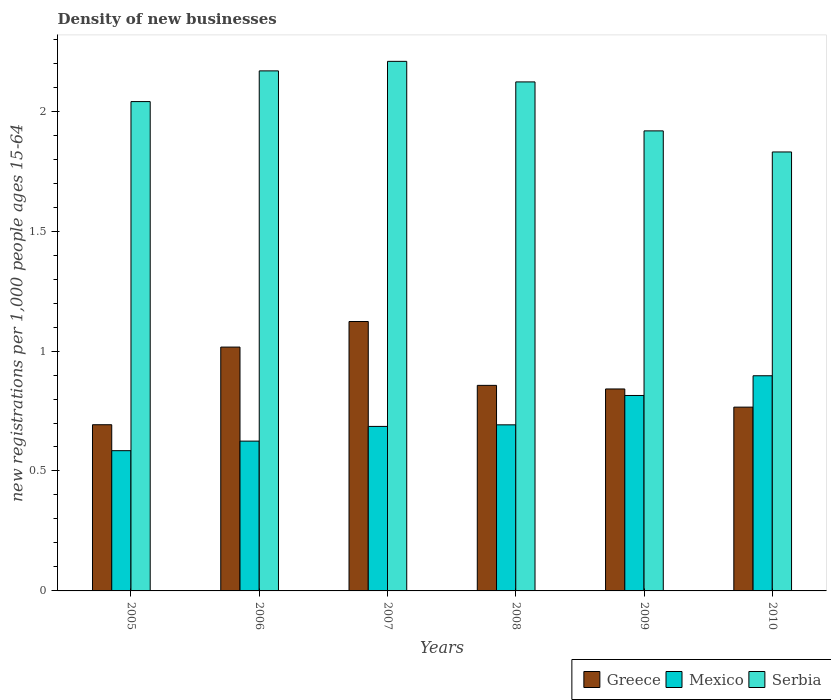How many different coloured bars are there?
Your answer should be very brief. 3. Are the number of bars per tick equal to the number of legend labels?
Your answer should be very brief. Yes. Are the number of bars on each tick of the X-axis equal?
Keep it short and to the point. Yes. What is the number of new registrations in Mexico in 2005?
Keep it short and to the point. 0.58. Across all years, what is the maximum number of new registrations in Greece?
Your answer should be very brief. 1.12. Across all years, what is the minimum number of new registrations in Greece?
Your answer should be compact. 0.69. What is the total number of new registrations in Serbia in the graph?
Provide a succinct answer. 12.29. What is the difference between the number of new registrations in Mexico in 2005 and that in 2006?
Provide a short and direct response. -0.04. What is the difference between the number of new registrations in Serbia in 2007 and the number of new registrations in Mexico in 2009?
Your answer should be compact. 1.39. What is the average number of new registrations in Serbia per year?
Offer a very short reply. 2.05. In the year 2005, what is the difference between the number of new registrations in Mexico and number of new registrations in Greece?
Your answer should be very brief. -0.11. What is the ratio of the number of new registrations in Mexico in 2008 to that in 2010?
Your answer should be compact. 0.77. What is the difference between the highest and the second highest number of new registrations in Mexico?
Keep it short and to the point. 0.08. What is the difference between the highest and the lowest number of new registrations in Greece?
Provide a short and direct response. 0.43. In how many years, is the number of new registrations in Mexico greater than the average number of new registrations in Mexico taken over all years?
Offer a very short reply. 2. Is the sum of the number of new registrations in Greece in 2005 and 2008 greater than the maximum number of new registrations in Mexico across all years?
Your answer should be compact. Yes. What does the 3rd bar from the left in 2008 represents?
Offer a very short reply. Serbia. What does the 1st bar from the right in 2005 represents?
Give a very brief answer. Serbia. Is it the case that in every year, the sum of the number of new registrations in Mexico and number of new registrations in Serbia is greater than the number of new registrations in Greece?
Offer a terse response. Yes. Are all the bars in the graph horizontal?
Make the answer very short. No. How many years are there in the graph?
Offer a very short reply. 6. What is the difference between two consecutive major ticks on the Y-axis?
Offer a very short reply. 0.5. Are the values on the major ticks of Y-axis written in scientific E-notation?
Your answer should be very brief. No. Where does the legend appear in the graph?
Keep it short and to the point. Bottom right. How many legend labels are there?
Ensure brevity in your answer.  3. How are the legend labels stacked?
Offer a terse response. Horizontal. What is the title of the graph?
Offer a terse response. Density of new businesses. What is the label or title of the Y-axis?
Your answer should be very brief. New registrations per 1,0 people ages 15-64. What is the new registrations per 1,000 people ages 15-64 of Greece in 2005?
Keep it short and to the point. 0.69. What is the new registrations per 1,000 people ages 15-64 of Mexico in 2005?
Offer a very short reply. 0.58. What is the new registrations per 1,000 people ages 15-64 in Serbia in 2005?
Make the answer very short. 2.04. What is the new registrations per 1,000 people ages 15-64 of Greece in 2006?
Ensure brevity in your answer.  1.02. What is the new registrations per 1,000 people ages 15-64 of Mexico in 2006?
Give a very brief answer. 0.62. What is the new registrations per 1,000 people ages 15-64 of Serbia in 2006?
Ensure brevity in your answer.  2.17. What is the new registrations per 1,000 people ages 15-64 of Greece in 2007?
Keep it short and to the point. 1.12. What is the new registrations per 1,000 people ages 15-64 of Mexico in 2007?
Offer a terse response. 0.69. What is the new registrations per 1,000 people ages 15-64 in Serbia in 2007?
Your answer should be compact. 2.21. What is the new registrations per 1,000 people ages 15-64 in Greece in 2008?
Offer a very short reply. 0.86. What is the new registrations per 1,000 people ages 15-64 of Mexico in 2008?
Provide a short and direct response. 0.69. What is the new registrations per 1,000 people ages 15-64 of Serbia in 2008?
Provide a short and direct response. 2.12. What is the new registrations per 1,000 people ages 15-64 of Greece in 2009?
Offer a very short reply. 0.84. What is the new registrations per 1,000 people ages 15-64 in Mexico in 2009?
Give a very brief answer. 0.81. What is the new registrations per 1,000 people ages 15-64 in Serbia in 2009?
Provide a succinct answer. 1.92. What is the new registrations per 1,000 people ages 15-64 in Greece in 2010?
Offer a terse response. 0.77. What is the new registrations per 1,000 people ages 15-64 of Mexico in 2010?
Give a very brief answer. 0.9. What is the new registrations per 1,000 people ages 15-64 in Serbia in 2010?
Keep it short and to the point. 1.83. Across all years, what is the maximum new registrations per 1,000 people ages 15-64 of Greece?
Ensure brevity in your answer.  1.12. Across all years, what is the maximum new registrations per 1,000 people ages 15-64 of Mexico?
Your answer should be compact. 0.9. Across all years, what is the maximum new registrations per 1,000 people ages 15-64 of Serbia?
Provide a succinct answer. 2.21. Across all years, what is the minimum new registrations per 1,000 people ages 15-64 of Greece?
Provide a succinct answer. 0.69. Across all years, what is the minimum new registrations per 1,000 people ages 15-64 of Mexico?
Offer a very short reply. 0.58. Across all years, what is the minimum new registrations per 1,000 people ages 15-64 of Serbia?
Offer a terse response. 1.83. What is the total new registrations per 1,000 people ages 15-64 of Greece in the graph?
Make the answer very short. 5.3. What is the total new registrations per 1,000 people ages 15-64 in Mexico in the graph?
Keep it short and to the point. 4.3. What is the total new registrations per 1,000 people ages 15-64 of Serbia in the graph?
Offer a very short reply. 12.29. What is the difference between the new registrations per 1,000 people ages 15-64 in Greece in 2005 and that in 2006?
Offer a terse response. -0.32. What is the difference between the new registrations per 1,000 people ages 15-64 in Mexico in 2005 and that in 2006?
Ensure brevity in your answer.  -0.04. What is the difference between the new registrations per 1,000 people ages 15-64 in Serbia in 2005 and that in 2006?
Your answer should be very brief. -0.13. What is the difference between the new registrations per 1,000 people ages 15-64 of Greece in 2005 and that in 2007?
Your response must be concise. -0.43. What is the difference between the new registrations per 1,000 people ages 15-64 of Mexico in 2005 and that in 2007?
Offer a terse response. -0.1. What is the difference between the new registrations per 1,000 people ages 15-64 of Serbia in 2005 and that in 2007?
Make the answer very short. -0.17. What is the difference between the new registrations per 1,000 people ages 15-64 in Greece in 2005 and that in 2008?
Offer a very short reply. -0.16. What is the difference between the new registrations per 1,000 people ages 15-64 in Mexico in 2005 and that in 2008?
Your response must be concise. -0.11. What is the difference between the new registrations per 1,000 people ages 15-64 of Serbia in 2005 and that in 2008?
Your response must be concise. -0.08. What is the difference between the new registrations per 1,000 people ages 15-64 in Greece in 2005 and that in 2009?
Your response must be concise. -0.15. What is the difference between the new registrations per 1,000 people ages 15-64 in Mexico in 2005 and that in 2009?
Your answer should be compact. -0.23. What is the difference between the new registrations per 1,000 people ages 15-64 of Serbia in 2005 and that in 2009?
Offer a terse response. 0.12. What is the difference between the new registrations per 1,000 people ages 15-64 in Greece in 2005 and that in 2010?
Offer a terse response. -0.07. What is the difference between the new registrations per 1,000 people ages 15-64 in Mexico in 2005 and that in 2010?
Give a very brief answer. -0.31. What is the difference between the new registrations per 1,000 people ages 15-64 in Serbia in 2005 and that in 2010?
Your answer should be very brief. 0.21. What is the difference between the new registrations per 1,000 people ages 15-64 of Greece in 2006 and that in 2007?
Provide a short and direct response. -0.11. What is the difference between the new registrations per 1,000 people ages 15-64 of Mexico in 2006 and that in 2007?
Make the answer very short. -0.06. What is the difference between the new registrations per 1,000 people ages 15-64 of Serbia in 2006 and that in 2007?
Your answer should be very brief. -0.04. What is the difference between the new registrations per 1,000 people ages 15-64 in Greece in 2006 and that in 2008?
Your answer should be compact. 0.16. What is the difference between the new registrations per 1,000 people ages 15-64 in Mexico in 2006 and that in 2008?
Offer a very short reply. -0.07. What is the difference between the new registrations per 1,000 people ages 15-64 of Serbia in 2006 and that in 2008?
Keep it short and to the point. 0.05. What is the difference between the new registrations per 1,000 people ages 15-64 in Greece in 2006 and that in 2009?
Provide a short and direct response. 0.17. What is the difference between the new registrations per 1,000 people ages 15-64 in Mexico in 2006 and that in 2009?
Provide a short and direct response. -0.19. What is the difference between the new registrations per 1,000 people ages 15-64 in Serbia in 2006 and that in 2009?
Your answer should be compact. 0.25. What is the difference between the new registrations per 1,000 people ages 15-64 in Greece in 2006 and that in 2010?
Offer a terse response. 0.25. What is the difference between the new registrations per 1,000 people ages 15-64 of Mexico in 2006 and that in 2010?
Ensure brevity in your answer.  -0.27. What is the difference between the new registrations per 1,000 people ages 15-64 of Serbia in 2006 and that in 2010?
Keep it short and to the point. 0.34. What is the difference between the new registrations per 1,000 people ages 15-64 of Greece in 2007 and that in 2008?
Keep it short and to the point. 0.27. What is the difference between the new registrations per 1,000 people ages 15-64 of Mexico in 2007 and that in 2008?
Your answer should be very brief. -0.01. What is the difference between the new registrations per 1,000 people ages 15-64 of Serbia in 2007 and that in 2008?
Offer a terse response. 0.09. What is the difference between the new registrations per 1,000 people ages 15-64 of Greece in 2007 and that in 2009?
Offer a very short reply. 0.28. What is the difference between the new registrations per 1,000 people ages 15-64 in Mexico in 2007 and that in 2009?
Give a very brief answer. -0.13. What is the difference between the new registrations per 1,000 people ages 15-64 of Serbia in 2007 and that in 2009?
Ensure brevity in your answer.  0.29. What is the difference between the new registrations per 1,000 people ages 15-64 in Greece in 2007 and that in 2010?
Provide a short and direct response. 0.36. What is the difference between the new registrations per 1,000 people ages 15-64 in Mexico in 2007 and that in 2010?
Provide a short and direct response. -0.21. What is the difference between the new registrations per 1,000 people ages 15-64 of Serbia in 2007 and that in 2010?
Make the answer very short. 0.38. What is the difference between the new registrations per 1,000 people ages 15-64 in Greece in 2008 and that in 2009?
Ensure brevity in your answer.  0.01. What is the difference between the new registrations per 1,000 people ages 15-64 of Mexico in 2008 and that in 2009?
Make the answer very short. -0.12. What is the difference between the new registrations per 1,000 people ages 15-64 of Serbia in 2008 and that in 2009?
Give a very brief answer. 0.2. What is the difference between the new registrations per 1,000 people ages 15-64 in Greece in 2008 and that in 2010?
Your answer should be compact. 0.09. What is the difference between the new registrations per 1,000 people ages 15-64 in Mexico in 2008 and that in 2010?
Your answer should be compact. -0.2. What is the difference between the new registrations per 1,000 people ages 15-64 in Serbia in 2008 and that in 2010?
Offer a very short reply. 0.29. What is the difference between the new registrations per 1,000 people ages 15-64 in Greece in 2009 and that in 2010?
Ensure brevity in your answer.  0.08. What is the difference between the new registrations per 1,000 people ages 15-64 in Mexico in 2009 and that in 2010?
Your answer should be very brief. -0.08. What is the difference between the new registrations per 1,000 people ages 15-64 in Serbia in 2009 and that in 2010?
Your answer should be compact. 0.09. What is the difference between the new registrations per 1,000 people ages 15-64 in Greece in 2005 and the new registrations per 1,000 people ages 15-64 in Mexico in 2006?
Your response must be concise. 0.07. What is the difference between the new registrations per 1,000 people ages 15-64 in Greece in 2005 and the new registrations per 1,000 people ages 15-64 in Serbia in 2006?
Give a very brief answer. -1.48. What is the difference between the new registrations per 1,000 people ages 15-64 in Mexico in 2005 and the new registrations per 1,000 people ages 15-64 in Serbia in 2006?
Your answer should be very brief. -1.58. What is the difference between the new registrations per 1,000 people ages 15-64 in Greece in 2005 and the new registrations per 1,000 people ages 15-64 in Mexico in 2007?
Your answer should be very brief. 0.01. What is the difference between the new registrations per 1,000 people ages 15-64 in Greece in 2005 and the new registrations per 1,000 people ages 15-64 in Serbia in 2007?
Your response must be concise. -1.51. What is the difference between the new registrations per 1,000 people ages 15-64 in Mexico in 2005 and the new registrations per 1,000 people ages 15-64 in Serbia in 2007?
Your answer should be compact. -1.62. What is the difference between the new registrations per 1,000 people ages 15-64 in Greece in 2005 and the new registrations per 1,000 people ages 15-64 in Serbia in 2008?
Offer a terse response. -1.43. What is the difference between the new registrations per 1,000 people ages 15-64 in Mexico in 2005 and the new registrations per 1,000 people ages 15-64 in Serbia in 2008?
Ensure brevity in your answer.  -1.54. What is the difference between the new registrations per 1,000 people ages 15-64 in Greece in 2005 and the new registrations per 1,000 people ages 15-64 in Mexico in 2009?
Your answer should be compact. -0.12. What is the difference between the new registrations per 1,000 people ages 15-64 in Greece in 2005 and the new registrations per 1,000 people ages 15-64 in Serbia in 2009?
Ensure brevity in your answer.  -1.23. What is the difference between the new registrations per 1,000 people ages 15-64 in Mexico in 2005 and the new registrations per 1,000 people ages 15-64 in Serbia in 2009?
Provide a succinct answer. -1.33. What is the difference between the new registrations per 1,000 people ages 15-64 of Greece in 2005 and the new registrations per 1,000 people ages 15-64 of Mexico in 2010?
Your answer should be very brief. -0.2. What is the difference between the new registrations per 1,000 people ages 15-64 of Greece in 2005 and the new registrations per 1,000 people ages 15-64 of Serbia in 2010?
Give a very brief answer. -1.14. What is the difference between the new registrations per 1,000 people ages 15-64 of Mexico in 2005 and the new registrations per 1,000 people ages 15-64 of Serbia in 2010?
Your answer should be compact. -1.25. What is the difference between the new registrations per 1,000 people ages 15-64 in Greece in 2006 and the new registrations per 1,000 people ages 15-64 in Mexico in 2007?
Your answer should be very brief. 0.33. What is the difference between the new registrations per 1,000 people ages 15-64 in Greece in 2006 and the new registrations per 1,000 people ages 15-64 in Serbia in 2007?
Your answer should be compact. -1.19. What is the difference between the new registrations per 1,000 people ages 15-64 of Mexico in 2006 and the new registrations per 1,000 people ages 15-64 of Serbia in 2007?
Your answer should be very brief. -1.58. What is the difference between the new registrations per 1,000 people ages 15-64 in Greece in 2006 and the new registrations per 1,000 people ages 15-64 in Mexico in 2008?
Offer a terse response. 0.32. What is the difference between the new registrations per 1,000 people ages 15-64 in Greece in 2006 and the new registrations per 1,000 people ages 15-64 in Serbia in 2008?
Offer a very short reply. -1.11. What is the difference between the new registrations per 1,000 people ages 15-64 of Mexico in 2006 and the new registrations per 1,000 people ages 15-64 of Serbia in 2008?
Provide a succinct answer. -1.5. What is the difference between the new registrations per 1,000 people ages 15-64 of Greece in 2006 and the new registrations per 1,000 people ages 15-64 of Mexico in 2009?
Offer a very short reply. 0.2. What is the difference between the new registrations per 1,000 people ages 15-64 of Greece in 2006 and the new registrations per 1,000 people ages 15-64 of Serbia in 2009?
Your answer should be very brief. -0.9. What is the difference between the new registrations per 1,000 people ages 15-64 of Mexico in 2006 and the new registrations per 1,000 people ages 15-64 of Serbia in 2009?
Your answer should be compact. -1.29. What is the difference between the new registrations per 1,000 people ages 15-64 of Greece in 2006 and the new registrations per 1,000 people ages 15-64 of Mexico in 2010?
Your answer should be compact. 0.12. What is the difference between the new registrations per 1,000 people ages 15-64 in Greece in 2006 and the new registrations per 1,000 people ages 15-64 in Serbia in 2010?
Ensure brevity in your answer.  -0.81. What is the difference between the new registrations per 1,000 people ages 15-64 in Mexico in 2006 and the new registrations per 1,000 people ages 15-64 in Serbia in 2010?
Provide a succinct answer. -1.21. What is the difference between the new registrations per 1,000 people ages 15-64 of Greece in 2007 and the new registrations per 1,000 people ages 15-64 of Mexico in 2008?
Offer a very short reply. 0.43. What is the difference between the new registrations per 1,000 people ages 15-64 in Greece in 2007 and the new registrations per 1,000 people ages 15-64 in Serbia in 2008?
Offer a very short reply. -1. What is the difference between the new registrations per 1,000 people ages 15-64 of Mexico in 2007 and the new registrations per 1,000 people ages 15-64 of Serbia in 2008?
Provide a succinct answer. -1.44. What is the difference between the new registrations per 1,000 people ages 15-64 of Greece in 2007 and the new registrations per 1,000 people ages 15-64 of Mexico in 2009?
Give a very brief answer. 0.31. What is the difference between the new registrations per 1,000 people ages 15-64 in Greece in 2007 and the new registrations per 1,000 people ages 15-64 in Serbia in 2009?
Keep it short and to the point. -0.79. What is the difference between the new registrations per 1,000 people ages 15-64 of Mexico in 2007 and the new registrations per 1,000 people ages 15-64 of Serbia in 2009?
Give a very brief answer. -1.23. What is the difference between the new registrations per 1,000 people ages 15-64 of Greece in 2007 and the new registrations per 1,000 people ages 15-64 of Mexico in 2010?
Ensure brevity in your answer.  0.23. What is the difference between the new registrations per 1,000 people ages 15-64 in Greece in 2007 and the new registrations per 1,000 people ages 15-64 in Serbia in 2010?
Offer a very short reply. -0.71. What is the difference between the new registrations per 1,000 people ages 15-64 in Mexico in 2007 and the new registrations per 1,000 people ages 15-64 in Serbia in 2010?
Make the answer very short. -1.14. What is the difference between the new registrations per 1,000 people ages 15-64 in Greece in 2008 and the new registrations per 1,000 people ages 15-64 in Mexico in 2009?
Your answer should be very brief. 0.04. What is the difference between the new registrations per 1,000 people ages 15-64 in Greece in 2008 and the new registrations per 1,000 people ages 15-64 in Serbia in 2009?
Your answer should be compact. -1.06. What is the difference between the new registrations per 1,000 people ages 15-64 in Mexico in 2008 and the new registrations per 1,000 people ages 15-64 in Serbia in 2009?
Provide a succinct answer. -1.23. What is the difference between the new registrations per 1,000 people ages 15-64 of Greece in 2008 and the new registrations per 1,000 people ages 15-64 of Mexico in 2010?
Give a very brief answer. -0.04. What is the difference between the new registrations per 1,000 people ages 15-64 in Greece in 2008 and the new registrations per 1,000 people ages 15-64 in Serbia in 2010?
Ensure brevity in your answer.  -0.97. What is the difference between the new registrations per 1,000 people ages 15-64 of Mexico in 2008 and the new registrations per 1,000 people ages 15-64 of Serbia in 2010?
Your answer should be very brief. -1.14. What is the difference between the new registrations per 1,000 people ages 15-64 of Greece in 2009 and the new registrations per 1,000 people ages 15-64 of Mexico in 2010?
Your answer should be very brief. -0.06. What is the difference between the new registrations per 1,000 people ages 15-64 of Greece in 2009 and the new registrations per 1,000 people ages 15-64 of Serbia in 2010?
Keep it short and to the point. -0.99. What is the difference between the new registrations per 1,000 people ages 15-64 in Mexico in 2009 and the new registrations per 1,000 people ages 15-64 in Serbia in 2010?
Give a very brief answer. -1.02. What is the average new registrations per 1,000 people ages 15-64 in Greece per year?
Offer a terse response. 0.88. What is the average new registrations per 1,000 people ages 15-64 of Mexico per year?
Keep it short and to the point. 0.72. What is the average new registrations per 1,000 people ages 15-64 in Serbia per year?
Your answer should be compact. 2.05. In the year 2005, what is the difference between the new registrations per 1,000 people ages 15-64 in Greece and new registrations per 1,000 people ages 15-64 in Mexico?
Provide a short and direct response. 0.11. In the year 2005, what is the difference between the new registrations per 1,000 people ages 15-64 of Greece and new registrations per 1,000 people ages 15-64 of Serbia?
Ensure brevity in your answer.  -1.35. In the year 2005, what is the difference between the new registrations per 1,000 people ages 15-64 of Mexico and new registrations per 1,000 people ages 15-64 of Serbia?
Offer a terse response. -1.46. In the year 2006, what is the difference between the new registrations per 1,000 people ages 15-64 of Greece and new registrations per 1,000 people ages 15-64 of Mexico?
Offer a terse response. 0.39. In the year 2006, what is the difference between the new registrations per 1,000 people ages 15-64 of Greece and new registrations per 1,000 people ages 15-64 of Serbia?
Give a very brief answer. -1.15. In the year 2006, what is the difference between the new registrations per 1,000 people ages 15-64 of Mexico and new registrations per 1,000 people ages 15-64 of Serbia?
Offer a very short reply. -1.54. In the year 2007, what is the difference between the new registrations per 1,000 people ages 15-64 in Greece and new registrations per 1,000 people ages 15-64 in Mexico?
Keep it short and to the point. 0.44. In the year 2007, what is the difference between the new registrations per 1,000 people ages 15-64 in Greece and new registrations per 1,000 people ages 15-64 in Serbia?
Ensure brevity in your answer.  -1.08. In the year 2007, what is the difference between the new registrations per 1,000 people ages 15-64 of Mexico and new registrations per 1,000 people ages 15-64 of Serbia?
Your answer should be very brief. -1.52. In the year 2008, what is the difference between the new registrations per 1,000 people ages 15-64 of Greece and new registrations per 1,000 people ages 15-64 of Mexico?
Your answer should be very brief. 0.16. In the year 2008, what is the difference between the new registrations per 1,000 people ages 15-64 in Greece and new registrations per 1,000 people ages 15-64 in Serbia?
Your response must be concise. -1.26. In the year 2008, what is the difference between the new registrations per 1,000 people ages 15-64 in Mexico and new registrations per 1,000 people ages 15-64 in Serbia?
Provide a succinct answer. -1.43. In the year 2009, what is the difference between the new registrations per 1,000 people ages 15-64 in Greece and new registrations per 1,000 people ages 15-64 in Mexico?
Provide a short and direct response. 0.03. In the year 2009, what is the difference between the new registrations per 1,000 people ages 15-64 in Greece and new registrations per 1,000 people ages 15-64 in Serbia?
Offer a very short reply. -1.08. In the year 2009, what is the difference between the new registrations per 1,000 people ages 15-64 in Mexico and new registrations per 1,000 people ages 15-64 in Serbia?
Your answer should be compact. -1.1. In the year 2010, what is the difference between the new registrations per 1,000 people ages 15-64 of Greece and new registrations per 1,000 people ages 15-64 of Mexico?
Give a very brief answer. -0.13. In the year 2010, what is the difference between the new registrations per 1,000 people ages 15-64 of Greece and new registrations per 1,000 people ages 15-64 of Serbia?
Give a very brief answer. -1.06. In the year 2010, what is the difference between the new registrations per 1,000 people ages 15-64 in Mexico and new registrations per 1,000 people ages 15-64 in Serbia?
Ensure brevity in your answer.  -0.93. What is the ratio of the new registrations per 1,000 people ages 15-64 of Greece in 2005 to that in 2006?
Keep it short and to the point. 0.68. What is the ratio of the new registrations per 1,000 people ages 15-64 of Mexico in 2005 to that in 2006?
Provide a succinct answer. 0.94. What is the ratio of the new registrations per 1,000 people ages 15-64 of Serbia in 2005 to that in 2006?
Make the answer very short. 0.94. What is the ratio of the new registrations per 1,000 people ages 15-64 of Greece in 2005 to that in 2007?
Keep it short and to the point. 0.62. What is the ratio of the new registrations per 1,000 people ages 15-64 in Mexico in 2005 to that in 2007?
Offer a very short reply. 0.85. What is the ratio of the new registrations per 1,000 people ages 15-64 of Serbia in 2005 to that in 2007?
Offer a very short reply. 0.92. What is the ratio of the new registrations per 1,000 people ages 15-64 in Greece in 2005 to that in 2008?
Keep it short and to the point. 0.81. What is the ratio of the new registrations per 1,000 people ages 15-64 in Mexico in 2005 to that in 2008?
Offer a very short reply. 0.84. What is the ratio of the new registrations per 1,000 people ages 15-64 in Serbia in 2005 to that in 2008?
Give a very brief answer. 0.96. What is the ratio of the new registrations per 1,000 people ages 15-64 in Greece in 2005 to that in 2009?
Give a very brief answer. 0.82. What is the ratio of the new registrations per 1,000 people ages 15-64 of Mexico in 2005 to that in 2009?
Keep it short and to the point. 0.72. What is the ratio of the new registrations per 1,000 people ages 15-64 in Serbia in 2005 to that in 2009?
Your response must be concise. 1.06. What is the ratio of the new registrations per 1,000 people ages 15-64 in Greece in 2005 to that in 2010?
Your response must be concise. 0.9. What is the ratio of the new registrations per 1,000 people ages 15-64 in Mexico in 2005 to that in 2010?
Ensure brevity in your answer.  0.65. What is the ratio of the new registrations per 1,000 people ages 15-64 in Serbia in 2005 to that in 2010?
Your answer should be compact. 1.11. What is the ratio of the new registrations per 1,000 people ages 15-64 in Greece in 2006 to that in 2007?
Give a very brief answer. 0.91. What is the ratio of the new registrations per 1,000 people ages 15-64 of Mexico in 2006 to that in 2007?
Provide a short and direct response. 0.91. What is the ratio of the new registrations per 1,000 people ages 15-64 in Serbia in 2006 to that in 2007?
Your answer should be compact. 0.98. What is the ratio of the new registrations per 1,000 people ages 15-64 in Greece in 2006 to that in 2008?
Keep it short and to the point. 1.19. What is the ratio of the new registrations per 1,000 people ages 15-64 in Mexico in 2006 to that in 2008?
Your answer should be very brief. 0.9. What is the ratio of the new registrations per 1,000 people ages 15-64 in Serbia in 2006 to that in 2008?
Your answer should be very brief. 1.02. What is the ratio of the new registrations per 1,000 people ages 15-64 in Greece in 2006 to that in 2009?
Give a very brief answer. 1.21. What is the ratio of the new registrations per 1,000 people ages 15-64 of Mexico in 2006 to that in 2009?
Give a very brief answer. 0.77. What is the ratio of the new registrations per 1,000 people ages 15-64 in Serbia in 2006 to that in 2009?
Provide a short and direct response. 1.13. What is the ratio of the new registrations per 1,000 people ages 15-64 of Greece in 2006 to that in 2010?
Your response must be concise. 1.33. What is the ratio of the new registrations per 1,000 people ages 15-64 of Mexico in 2006 to that in 2010?
Provide a succinct answer. 0.7. What is the ratio of the new registrations per 1,000 people ages 15-64 in Serbia in 2006 to that in 2010?
Your answer should be very brief. 1.18. What is the ratio of the new registrations per 1,000 people ages 15-64 of Greece in 2007 to that in 2008?
Your answer should be compact. 1.31. What is the ratio of the new registrations per 1,000 people ages 15-64 in Mexico in 2007 to that in 2008?
Offer a terse response. 0.99. What is the ratio of the new registrations per 1,000 people ages 15-64 of Serbia in 2007 to that in 2008?
Provide a succinct answer. 1.04. What is the ratio of the new registrations per 1,000 people ages 15-64 in Greece in 2007 to that in 2009?
Your response must be concise. 1.33. What is the ratio of the new registrations per 1,000 people ages 15-64 of Mexico in 2007 to that in 2009?
Your answer should be very brief. 0.84. What is the ratio of the new registrations per 1,000 people ages 15-64 of Serbia in 2007 to that in 2009?
Make the answer very short. 1.15. What is the ratio of the new registrations per 1,000 people ages 15-64 of Greece in 2007 to that in 2010?
Your answer should be very brief. 1.47. What is the ratio of the new registrations per 1,000 people ages 15-64 of Mexico in 2007 to that in 2010?
Your response must be concise. 0.76. What is the ratio of the new registrations per 1,000 people ages 15-64 in Serbia in 2007 to that in 2010?
Make the answer very short. 1.21. What is the ratio of the new registrations per 1,000 people ages 15-64 of Greece in 2008 to that in 2009?
Provide a succinct answer. 1.02. What is the ratio of the new registrations per 1,000 people ages 15-64 of Mexico in 2008 to that in 2009?
Offer a very short reply. 0.85. What is the ratio of the new registrations per 1,000 people ages 15-64 in Serbia in 2008 to that in 2009?
Provide a short and direct response. 1.11. What is the ratio of the new registrations per 1,000 people ages 15-64 in Greece in 2008 to that in 2010?
Provide a short and direct response. 1.12. What is the ratio of the new registrations per 1,000 people ages 15-64 in Mexico in 2008 to that in 2010?
Your answer should be very brief. 0.77. What is the ratio of the new registrations per 1,000 people ages 15-64 of Serbia in 2008 to that in 2010?
Provide a short and direct response. 1.16. What is the ratio of the new registrations per 1,000 people ages 15-64 of Greece in 2009 to that in 2010?
Make the answer very short. 1.1. What is the ratio of the new registrations per 1,000 people ages 15-64 of Mexico in 2009 to that in 2010?
Make the answer very short. 0.91. What is the ratio of the new registrations per 1,000 people ages 15-64 in Serbia in 2009 to that in 2010?
Make the answer very short. 1.05. What is the difference between the highest and the second highest new registrations per 1,000 people ages 15-64 of Greece?
Provide a succinct answer. 0.11. What is the difference between the highest and the second highest new registrations per 1,000 people ages 15-64 in Mexico?
Keep it short and to the point. 0.08. What is the difference between the highest and the second highest new registrations per 1,000 people ages 15-64 in Serbia?
Provide a short and direct response. 0.04. What is the difference between the highest and the lowest new registrations per 1,000 people ages 15-64 in Greece?
Your answer should be compact. 0.43. What is the difference between the highest and the lowest new registrations per 1,000 people ages 15-64 in Mexico?
Your answer should be compact. 0.31. What is the difference between the highest and the lowest new registrations per 1,000 people ages 15-64 of Serbia?
Offer a very short reply. 0.38. 